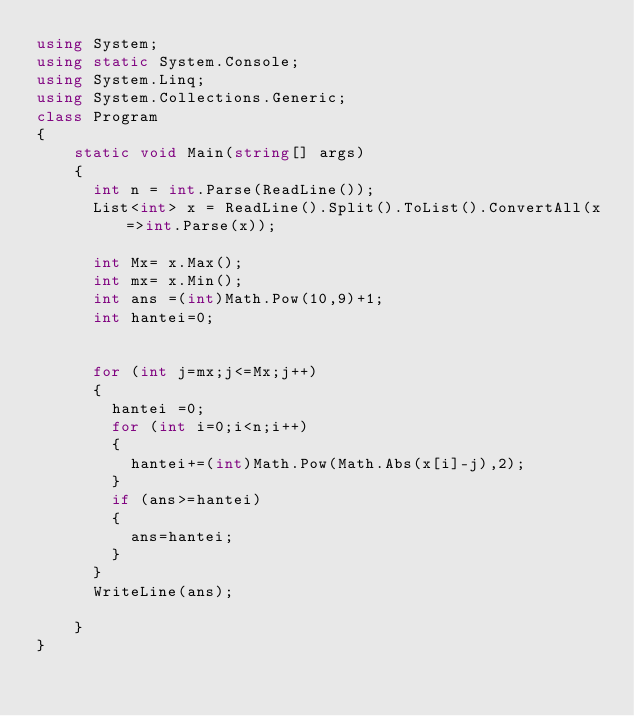Convert code to text. <code><loc_0><loc_0><loc_500><loc_500><_C#_>using System;
using static System.Console;
using System.Linq;
using System.Collections.Generic;
class Program
{
    static void Main(string[] args)
    {
      int n = int.Parse(ReadLine());
      List<int> x = ReadLine().Split().ToList().ConvertAll(x=>int.Parse(x));
      
      int Mx= x.Max();
      int mx= x.Min();
      int ans =(int)Math.Pow(10,9)+1;
      int hantei=0;
      
      
      for (int j=mx;j<=Mx;j++)
      {
        hantei =0;
        for (int i=0;i<n;i++)
        {
          hantei+=(int)Math.Pow(Math.Abs(x[i]-j),2);
        }
        if (ans>=hantei)
        {
          ans=hantei;
        }
      }
      WriteLine(ans);
      
    }
}</code> 